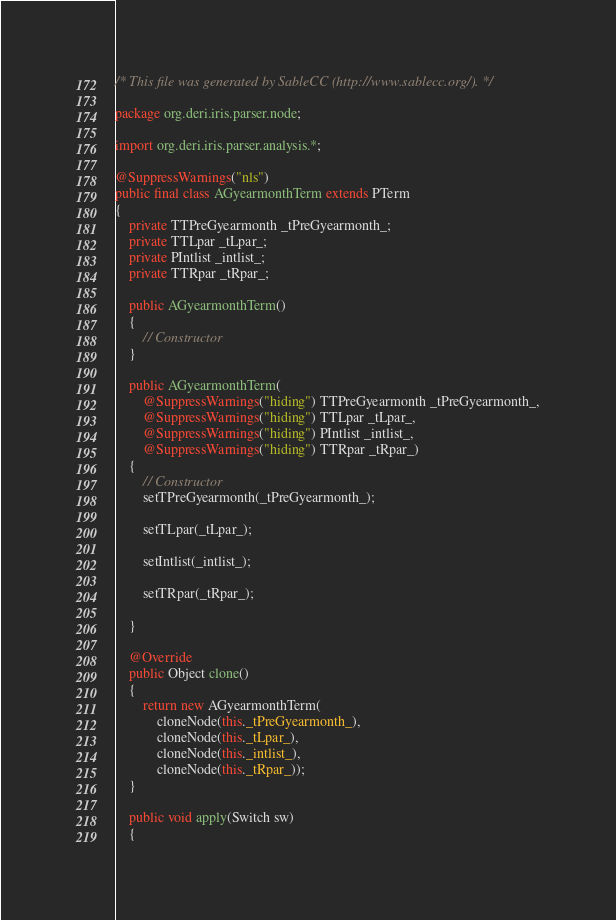<code> <loc_0><loc_0><loc_500><loc_500><_Java_>/* This file was generated by SableCC (http://www.sablecc.org/). */

package org.deri.iris.parser.node;

import org.deri.iris.parser.analysis.*;

@SuppressWarnings("nls")
public final class AGyearmonthTerm extends PTerm
{
    private TTPreGyearmonth _tPreGyearmonth_;
    private TTLpar _tLpar_;
    private PIntlist _intlist_;
    private TTRpar _tRpar_;

    public AGyearmonthTerm()
    {
        // Constructor
    }

    public AGyearmonthTerm(
        @SuppressWarnings("hiding") TTPreGyearmonth _tPreGyearmonth_,
        @SuppressWarnings("hiding") TTLpar _tLpar_,
        @SuppressWarnings("hiding") PIntlist _intlist_,
        @SuppressWarnings("hiding") TTRpar _tRpar_)
    {
        // Constructor
        setTPreGyearmonth(_tPreGyearmonth_);

        setTLpar(_tLpar_);

        setIntlist(_intlist_);

        setTRpar(_tRpar_);

    }

    @Override
    public Object clone()
    {
        return new AGyearmonthTerm(
            cloneNode(this._tPreGyearmonth_),
            cloneNode(this._tLpar_),
            cloneNode(this._intlist_),
            cloneNode(this._tRpar_));
    }

    public void apply(Switch sw)
    {</code> 